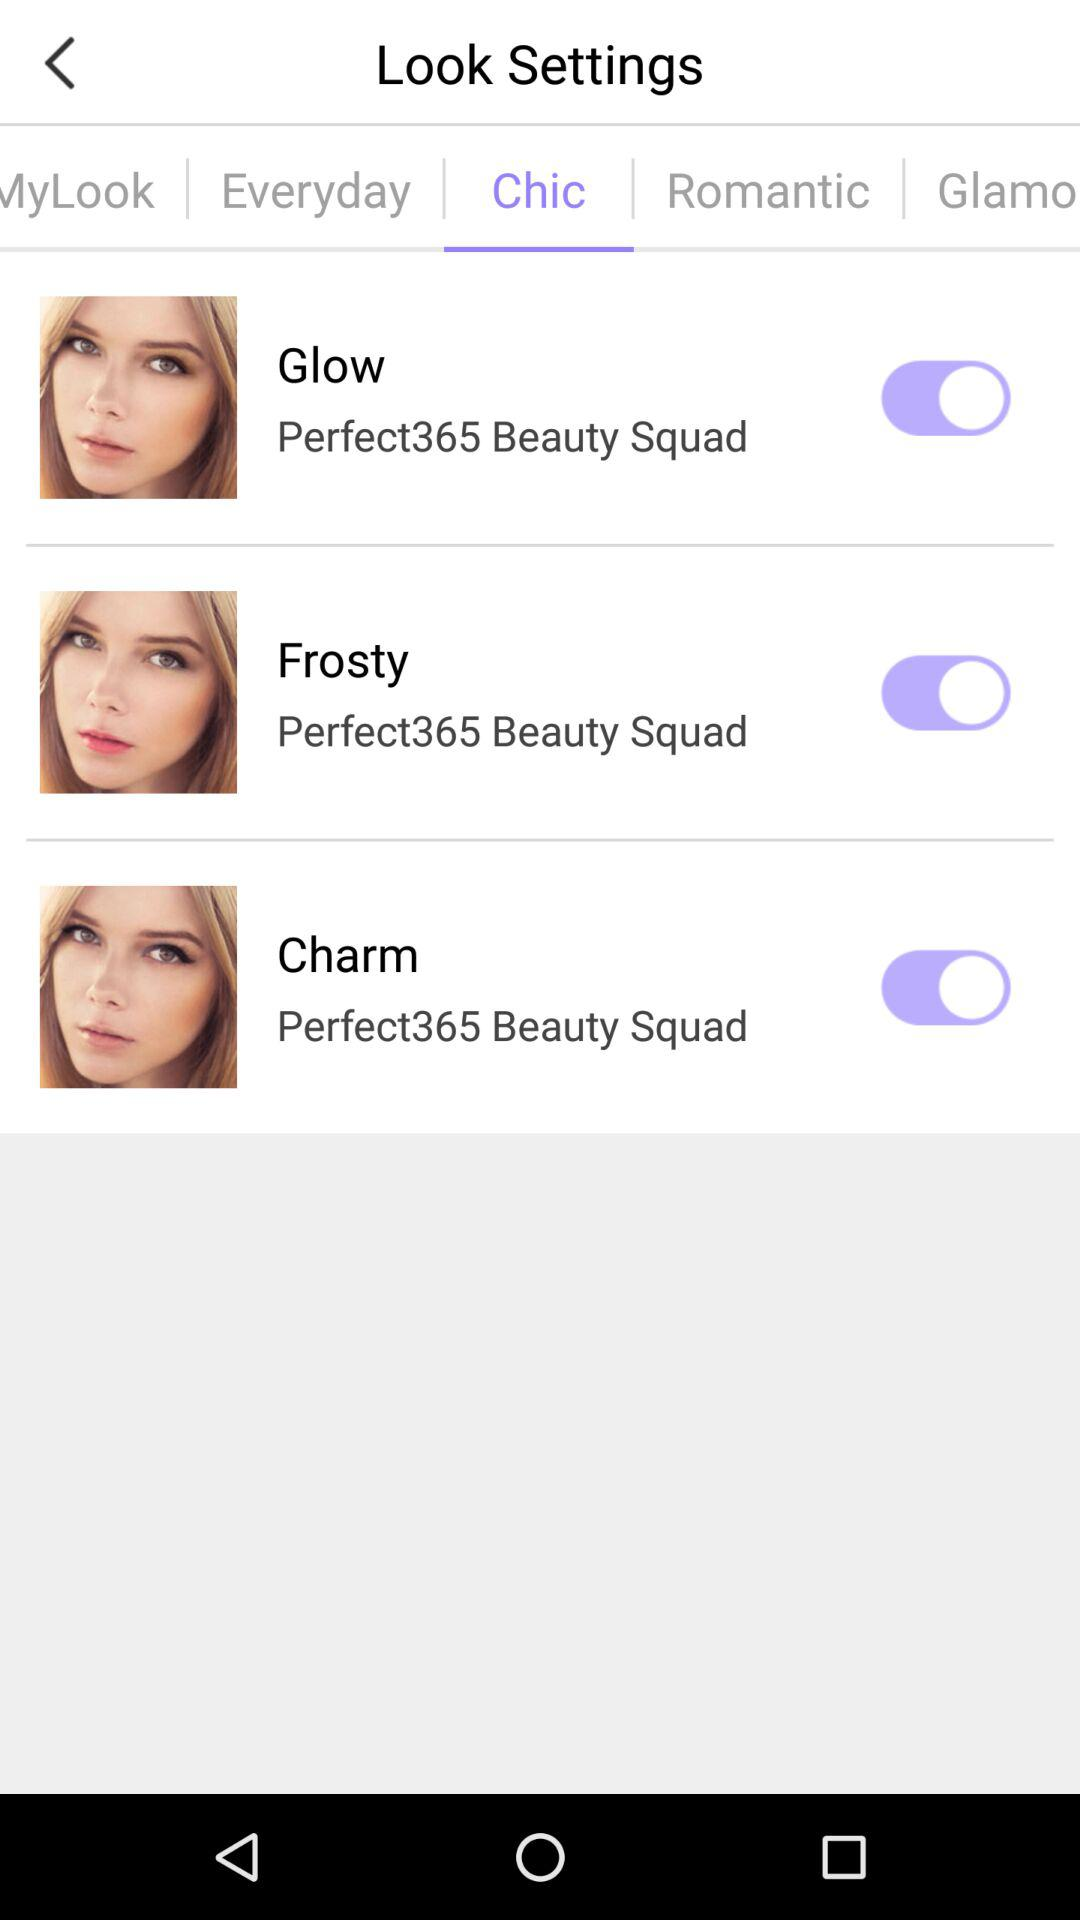How many more Perfect365 Beauty Squad labels are there than arrows?
Answer the question using a single word or phrase. 2 